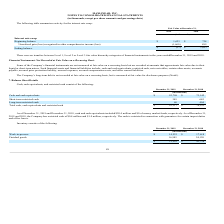According to Maxlinear's financial document, What were the transfers between Level 1, Level 2 and Level 3 in 2019 and 2018? There were no transfers between Level 1, Level 2 or Level 3. The document states: "There were no transfers between Level 1, Level 2 or Level 3 fair value hierarchy categories of financial instruments in the years ended December 31, 2..." Also, How is the company's long-term debt recorded? Based on the financial document, the answer is measured at fair value for disclosure purposes (Note8 ). Also, What was the Unrealized gain (loss) recognized in other comprehensive income (loss) in 2019 and 2018 respectively? The document shows two values: (1,660) and 889 (in thousands). From the document: "ized in other comprehensive income (loss) (1,660) 889 s) recognized in other comprehensive income (loss) (1,660) 889..." Additionally, In which year was the beginning balance less than 1,000 thousands? According to the financial document, 2018. The relevant text states: "2019 2018..." Also, can you calculate: What was the average Unrealized gain (loss) recognized in other comprehensive income (loss) for 2018 and 2019? To answer this question, I need to perform calculations using the financial data. The calculation is: (-1,660 + 889) / 2, which equals -385.5 (in thousands). This is based on the information: "ized in other comprehensive income (loss) (1,660) 889 recognized in other comprehensive income (loss) (1,660) 889..." The key data points involved are: 1,660, 889. Also, can you calculate: What was the change in the ending balance from 2018 to 2019? Based on the calculation: -37 - 1,623, the result is -1660 (in thousands). This is based on the information: "Ending balance $ (37) $ 1,623 Beginning balance $ 1,623 $ 734..." The key data points involved are: 1,623, 37. 